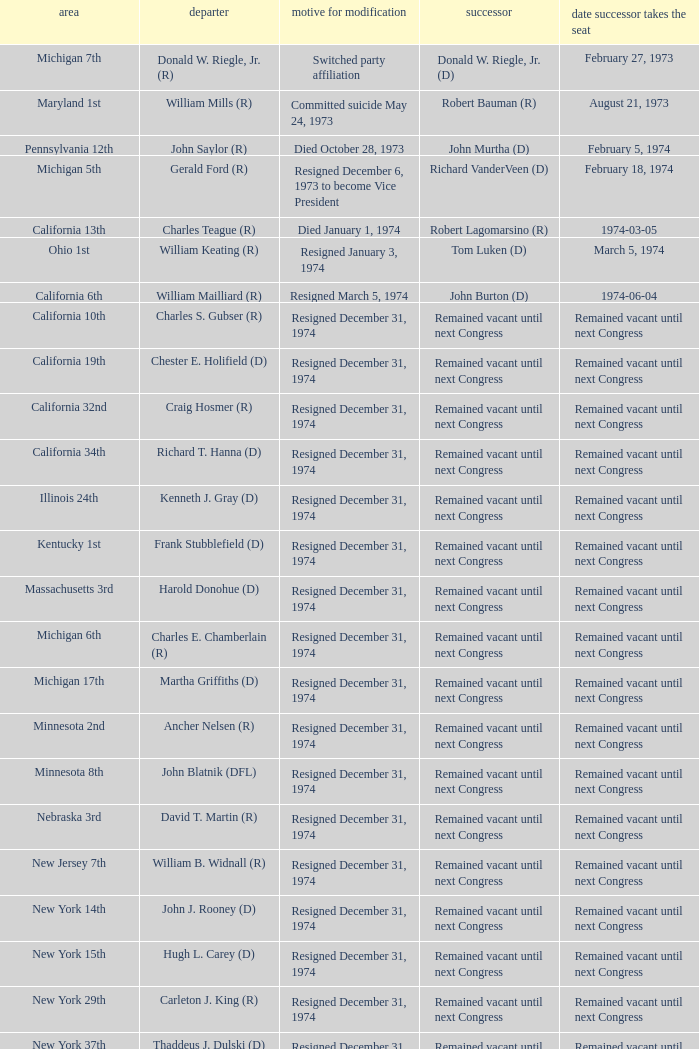Who was the vacator when the date successor seated was august 21, 1973? William Mills (R). Could you parse the entire table as a dict? {'header': ['area', 'departer', 'motive for modification', 'successor', 'date successor takes the seat'], 'rows': [['Michigan 7th', 'Donald W. Riegle, Jr. (R)', 'Switched party affiliation', 'Donald W. Riegle, Jr. (D)', 'February 27, 1973'], ['Maryland 1st', 'William Mills (R)', 'Committed suicide May 24, 1973', 'Robert Bauman (R)', 'August 21, 1973'], ['Pennsylvania 12th', 'John Saylor (R)', 'Died October 28, 1973', 'John Murtha (D)', 'February 5, 1974'], ['Michigan 5th', 'Gerald Ford (R)', 'Resigned December 6, 1973 to become Vice President', 'Richard VanderVeen (D)', 'February 18, 1974'], ['California 13th', 'Charles Teague (R)', 'Died January 1, 1974', 'Robert Lagomarsino (R)', '1974-03-05'], ['Ohio 1st', 'William Keating (R)', 'Resigned January 3, 1974', 'Tom Luken (D)', 'March 5, 1974'], ['California 6th', 'William Mailliard (R)', 'Resigned March 5, 1974', 'John Burton (D)', '1974-06-04'], ['California 10th', 'Charles S. Gubser (R)', 'Resigned December 31, 1974', 'Remained vacant until next Congress', 'Remained vacant until next Congress'], ['California 19th', 'Chester E. Holifield (D)', 'Resigned December 31, 1974', 'Remained vacant until next Congress', 'Remained vacant until next Congress'], ['California 32nd', 'Craig Hosmer (R)', 'Resigned December 31, 1974', 'Remained vacant until next Congress', 'Remained vacant until next Congress'], ['California 34th', 'Richard T. Hanna (D)', 'Resigned December 31, 1974', 'Remained vacant until next Congress', 'Remained vacant until next Congress'], ['Illinois 24th', 'Kenneth J. Gray (D)', 'Resigned December 31, 1974', 'Remained vacant until next Congress', 'Remained vacant until next Congress'], ['Kentucky 1st', 'Frank Stubblefield (D)', 'Resigned December 31, 1974', 'Remained vacant until next Congress', 'Remained vacant until next Congress'], ['Massachusetts 3rd', 'Harold Donohue (D)', 'Resigned December 31, 1974', 'Remained vacant until next Congress', 'Remained vacant until next Congress'], ['Michigan 6th', 'Charles E. Chamberlain (R)', 'Resigned December 31, 1974', 'Remained vacant until next Congress', 'Remained vacant until next Congress'], ['Michigan 17th', 'Martha Griffiths (D)', 'Resigned December 31, 1974', 'Remained vacant until next Congress', 'Remained vacant until next Congress'], ['Minnesota 2nd', 'Ancher Nelsen (R)', 'Resigned December 31, 1974', 'Remained vacant until next Congress', 'Remained vacant until next Congress'], ['Minnesota 8th', 'John Blatnik (DFL)', 'Resigned December 31, 1974', 'Remained vacant until next Congress', 'Remained vacant until next Congress'], ['Nebraska 3rd', 'David T. Martin (R)', 'Resigned December 31, 1974', 'Remained vacant until next Congress', 'Remained vacant until next Congress'], ['New Jersey 7th', 'William B. Widnall (R)', 'Resigned December 31, 1974', 'Remained vacant until next Congress', 'Remained vacant until next Congress'], ['New York 14th', 'John J. Rooney (D)', 'Resigned December 31, 1974', 'Remained vacant until next Congress', 'Remained vacant until next Congress'], ['New York 15th', 'Hugh L. Carey (D)', 'Resigned December 31, 1974', 'Remained vacant until next Congress', 'Remained vacant until next Congress'], ['New York 29th', 'Carleton J. King (R)', 'Resigned December 31, 1974', 'Remained vacant until next Congress', 'Remained vacant until next Congress'], ['New York 37th', 'Thaddeus J. Dulski (D)', 'Resigned December 31, 1974', 'Remained vacant until next Congress', 'Remained vacant until next Congress'], ['Ohio 23rd', 'William Minshall (R)', 'Resigned December 31, 1974', 'Remained vacant until next Congress', 'Remained vacant until next Congress'], ['Oregon 3rd', 'Edith S. Green (D)', 'Resigned December 31, 1974', 'Remained vacant until next Congress', 'Remained vacant until next Congress'], ['Pennsylvania 25th', 'Frank M. Clark (D)', 'Resigned December 31, 1974', 'Remained vacant until next Congress', 'Remained vacant until next Congress'], ['South Carolina 3rd', 'W.J. Bryan Dorn (D)', 'Resigned December 31, 1974', 'Remained vacant until next Congress', 'Remained vacant until next Congress'], ['South Carolina 5th', 'Thomas S. Gettys (D)', 'Resigned December 31, 1974', 'Remained vacant until next Congress', 'Remained vacant until next Congress'], ['Texas 21st', 'O. C. Fisher (D)', 'Resigned December 31, 1974', 'Remained vacant until next Congress', 'Remained vacant until next Congress'], ['Washington 3rd', 'Julia B. Hansen (D)', 'Resigned December 31, 1974', 'Remained vacant until next Congress', 'Remained vacant until next Congress'], ['Wisconsin 3rd', 'Vernon W. Thomson (R)', 'Resigned December 31, 1974', 'Remained vacant until next Congress', 'Remained vacant until next Congress']]} 